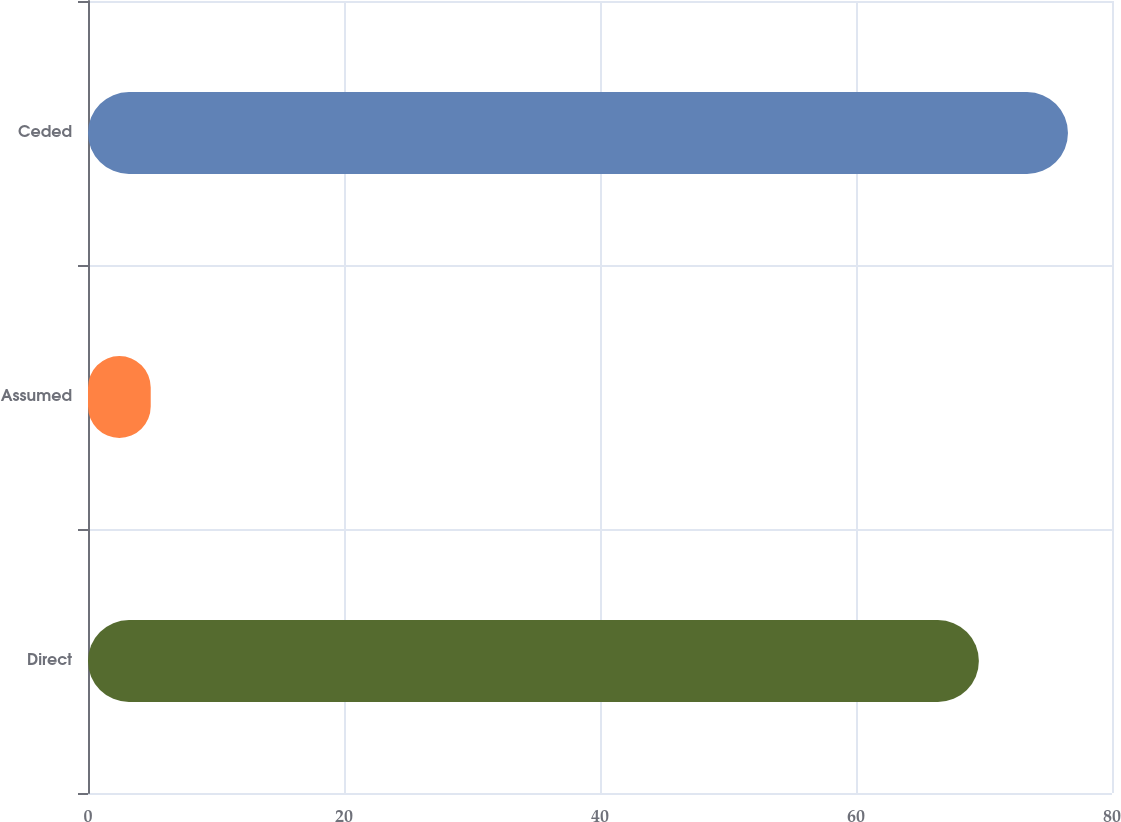Convert chart to OTSL. <chart><loc_0><loc_0><loc_500><loc_500><bar_chart><fcel>Direct<fcel>Assumed<fcel>Ceded<nl><fcel>69.6<fcel>4.9<fcel>76.56<nl></chart> 